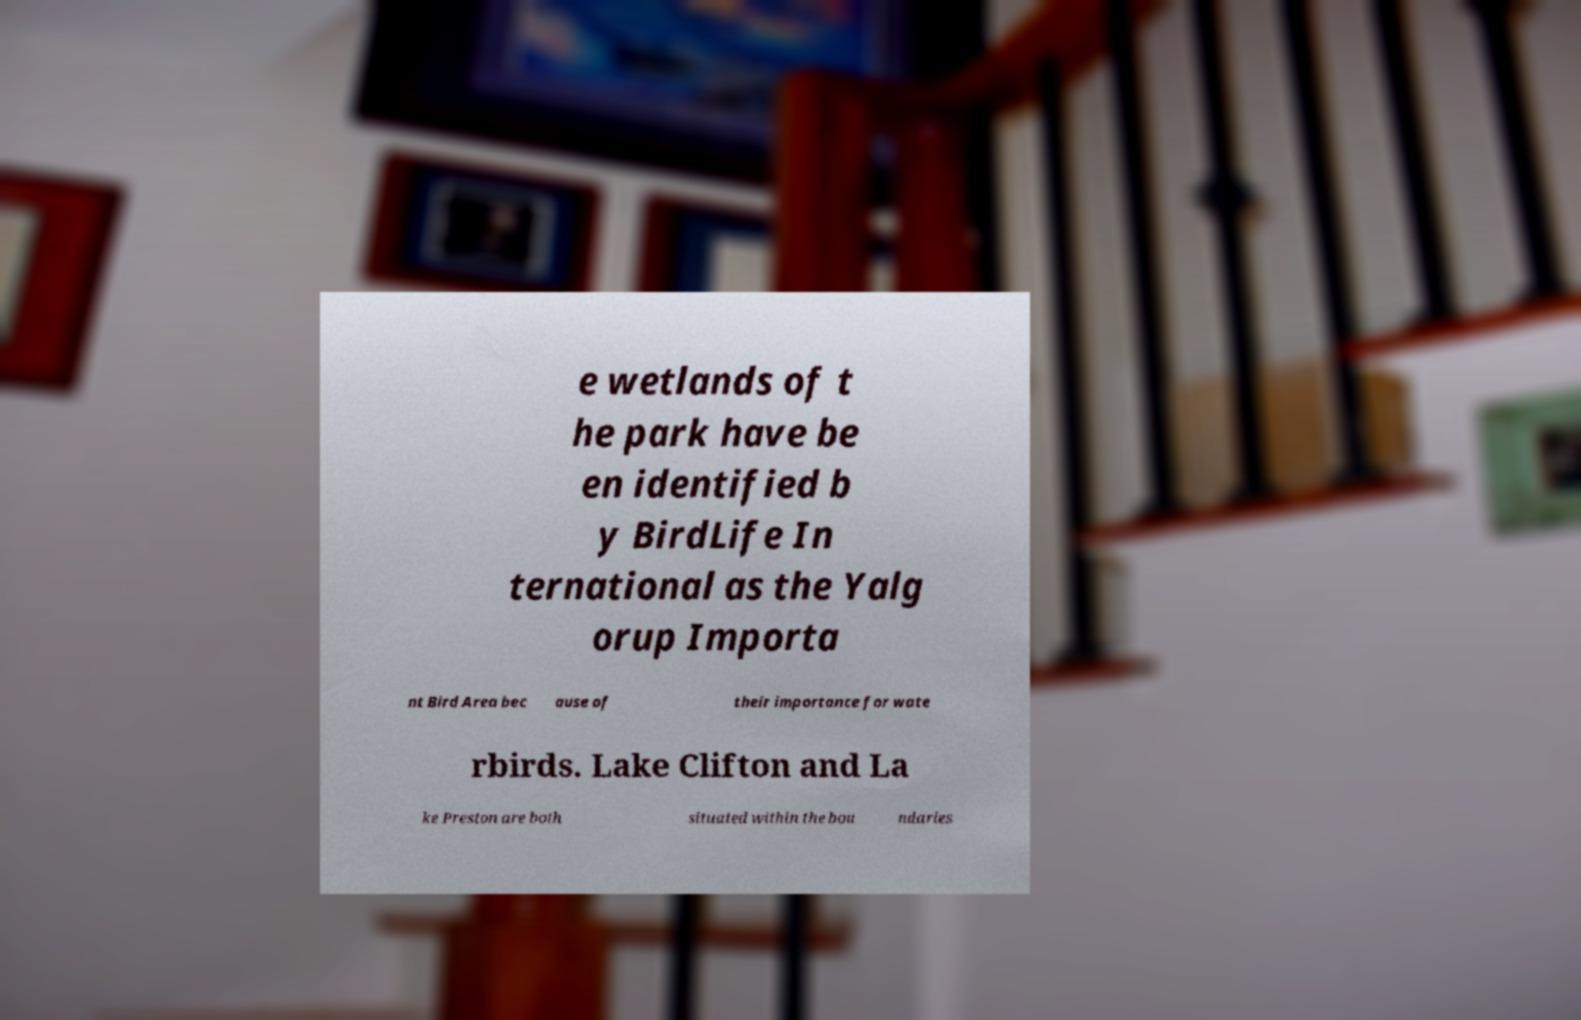Can you read and provide the text displayed in the image?This photo seems to have some interesting text. Can you extract and type it out for me? e wetlands of t he park have be en identified b y BirdLife In ternational as the Yalg orup Importa nt Bird Area bec ause of their importance for wate rbirds. Lake Clifton and La ke Preston are both situated within the bou ndaries 